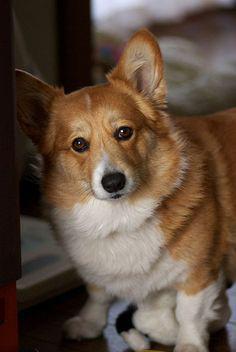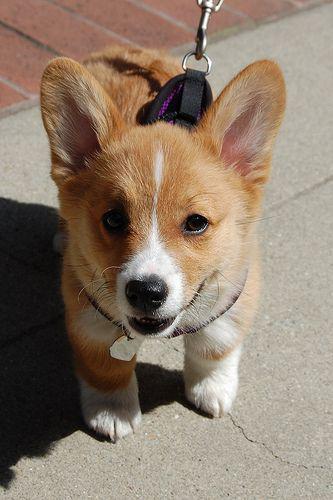The first image is the image on the left, the second image is the image on the right. For the images shown, is this caption "The dog in the image on the right is on a leasch" true? Answer yes or no. Yes. The first image is the image on the left, the second image is the image on the right. Given the left and right images, does the statement "There is one Corgi on a leash." hold true? Answer yes or no. Yes. 